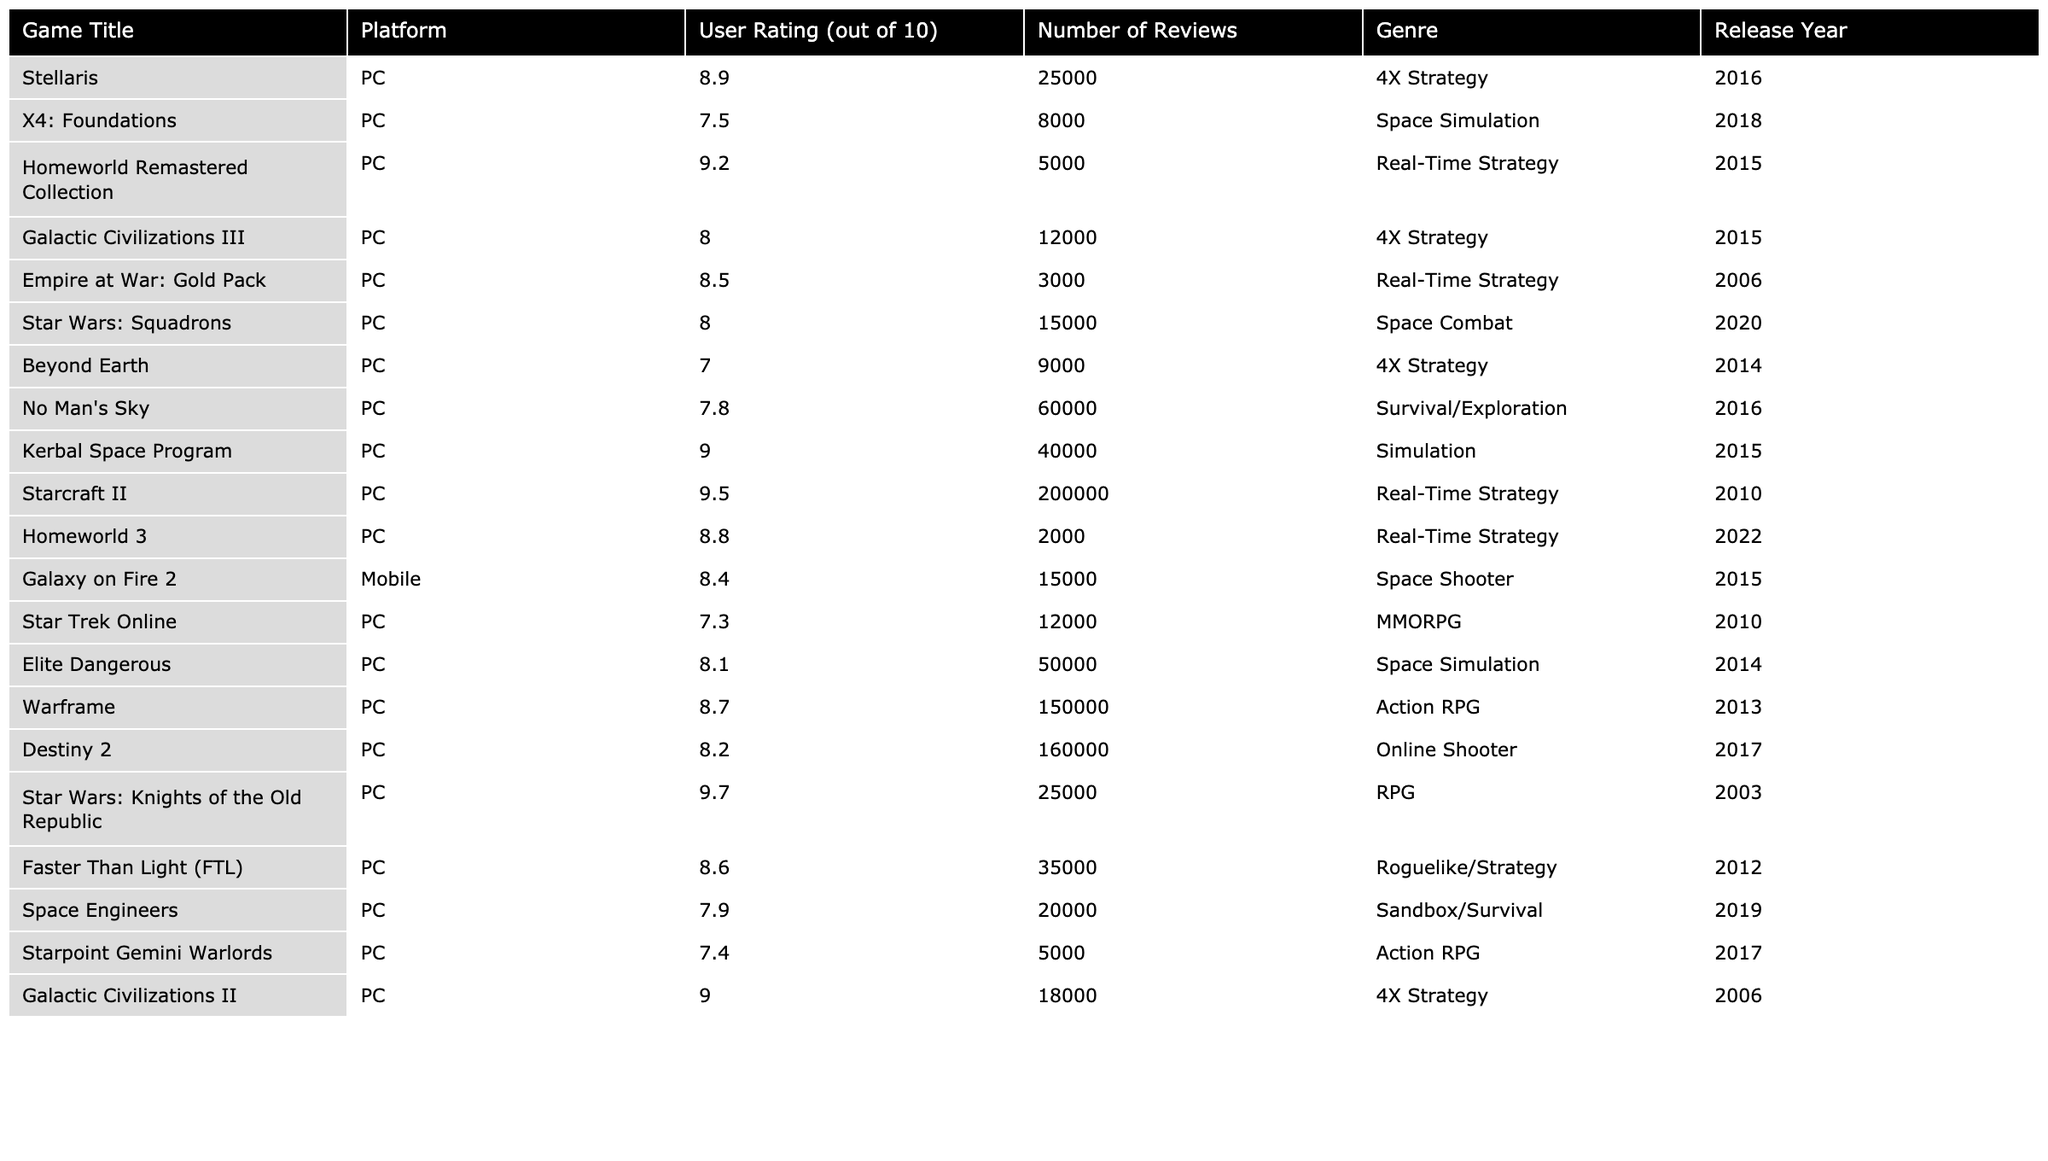What is the user rating of "Starcraft II"? The user rating for "Starcraft II" is specified in the table, and it is given as 9.5 out of 10.
Answer: 9.5 Which game has the highest user rating? By inspecting the user ratings in the table, "Star Wars: Knights of the Old Republic" has the highest user rating of 9.7.
Answer: 9.7 How many reviews does "No Man's Sky" have? The table shows that "No Man's Sky" has a total of 60,000 user reviews.
Answer: 60000 What is the average user rating of all listed games? By summing all user ratings from the table (8.9 + 7.5 + 9.2 + 8.0 + 8.5 + 8.0 + 7.0 + 7.8 + 9.0 + 9.5 + 8.8 + 8.4 + 7.3 + 8.1 + 8.7 + 8.2 + 9.7 + 8.6 + 7.9 + 7.4 + 9.0) = 171.8 and dividing by the number of games (21), the average is approximately 8.17.
Answer: 8.17 Is "Homeworld Remastered Collection" a 4X strategy game? According to the table, "Homeworld Remastered Collection" is categorized under "Real-Time Strategy," so this statement is false.
Answer: No Which platform has the most user reviews across all games? By comparing the number of reviews for each platform in the table, we see that the PC platform has the highest total reviews (367,000) when summed up.
Answer: PC What is the difference in user ratings between "X4: Foundations" and "Galactic Civilizations III"? The user rating for "X4: Foundations" is 7.5 and for "Galactic Civilizations III" it is 8.0. The difference is 8.0 - 7.5 = 0.5.
Answer: 0.5 Which two games have user ratings below 8.0, and what are their ratings? The table indicates that "Beyond Earth" has a rating of 7.0, and "Starpoint Gemini Warlords" has a rating of 7.4. Both are below 8.0.
Answer: Beyond Earth: 7.0, Starpoint Gemini Warlords: 7.4 What is the total number of reviews for all games released after 2010? The total reviews for games released after 2010 (Starcraft II: 200,000; Warframe: 150,000; Destiny 2: 160,000; Homeworld 3: 2,000; Star Wars: Squadrons: 15,000) sum up to 527,000.
Answer: 527000 Which game has the most reviews and what is its user rating? The game with the most reviews is "Starcraft II" with 200,000 reviews, and its user rating is 9.5.
Answer: Starcraft II: 200,000 reviews, rating 9.5 